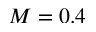<formula> <loc_0><loc_0><loc_500><loc_500>M = 0 . 4</formula> 